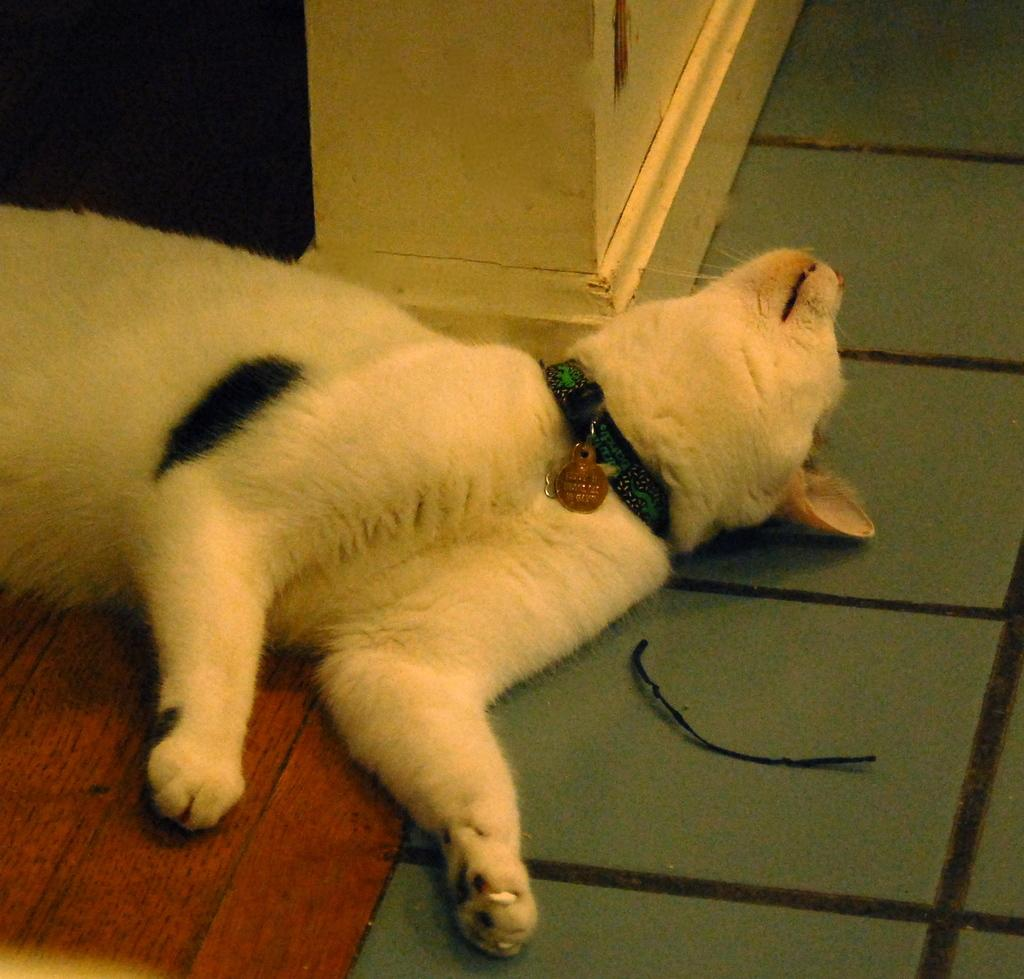What type of animal can be seen in the image? There is a dog in the image. What is the dog doing in the image? The dog is lying on the floor. What can be seen in the background of the image? There is a wall in the image, and the background is dark. What type of government is depicted in the image? There is no depiction of a government in the image; it features a dog lying on the floor. How many pigs are visible in the image? There are no pigs present in the image. 